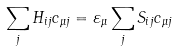<formula> <loc_0><loc_0><loc_500><loc_500>\sum _ { j } H _ { i j } c _ { \mu j } = \varepsilon _ { \mu } \sum _ { j } S _ { i j } c _ { \mu j }</formula> 